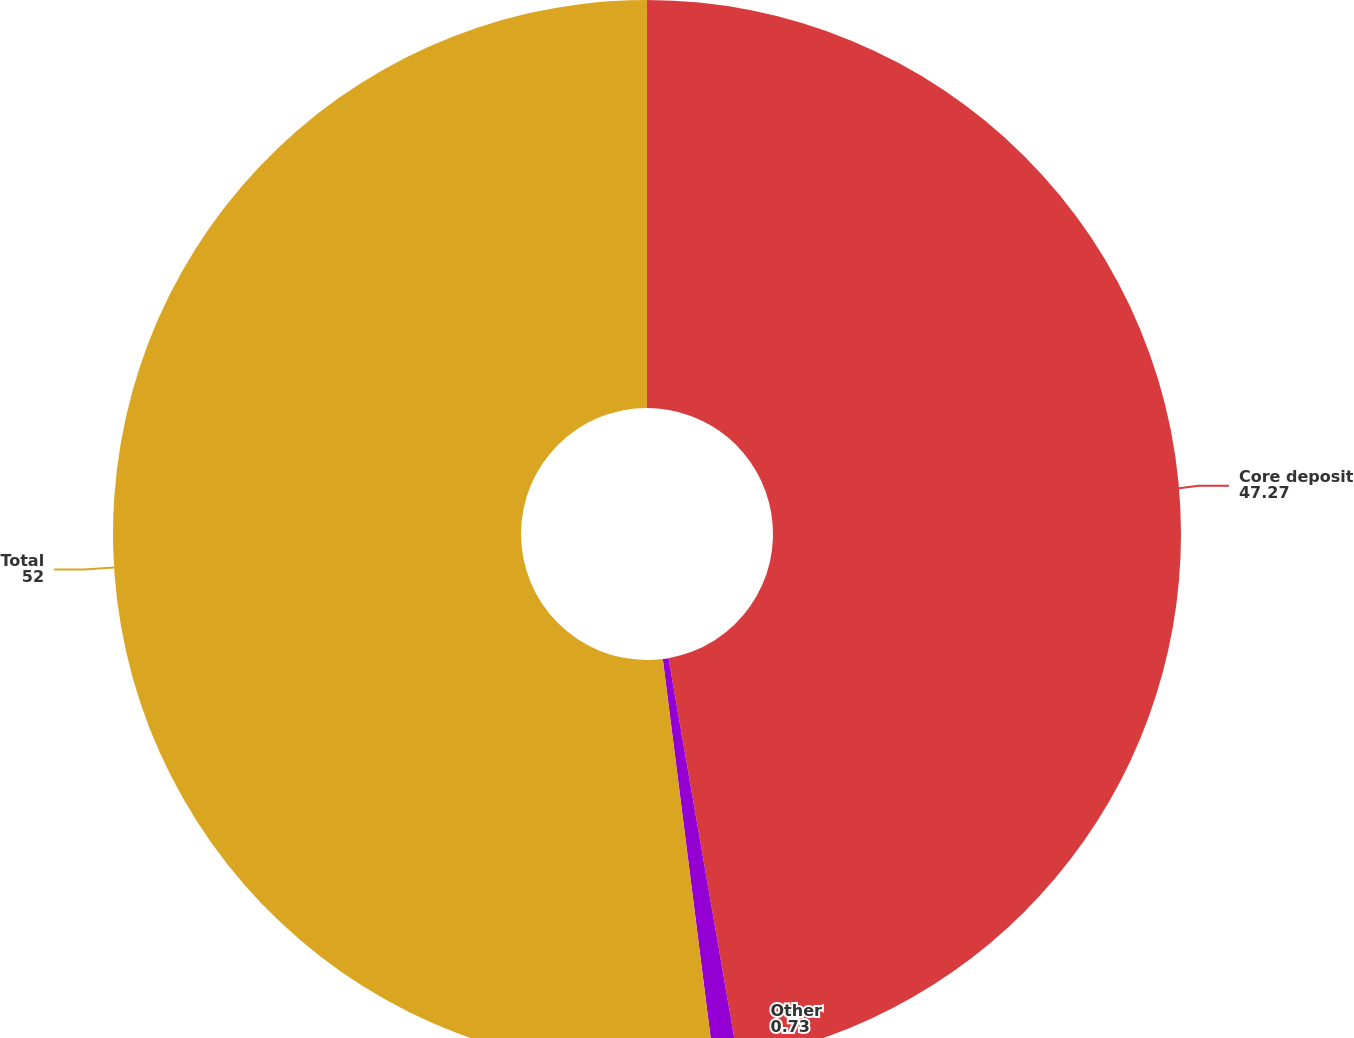<chart> <loc_0><loc_0><loc_500><loc_500><pie_chart><fcel>Core deposit<fcel>Other<fcel>Total<nl><fcel>47.27%<fcel>0.73%<fcel>52.0%<nl></chart> 